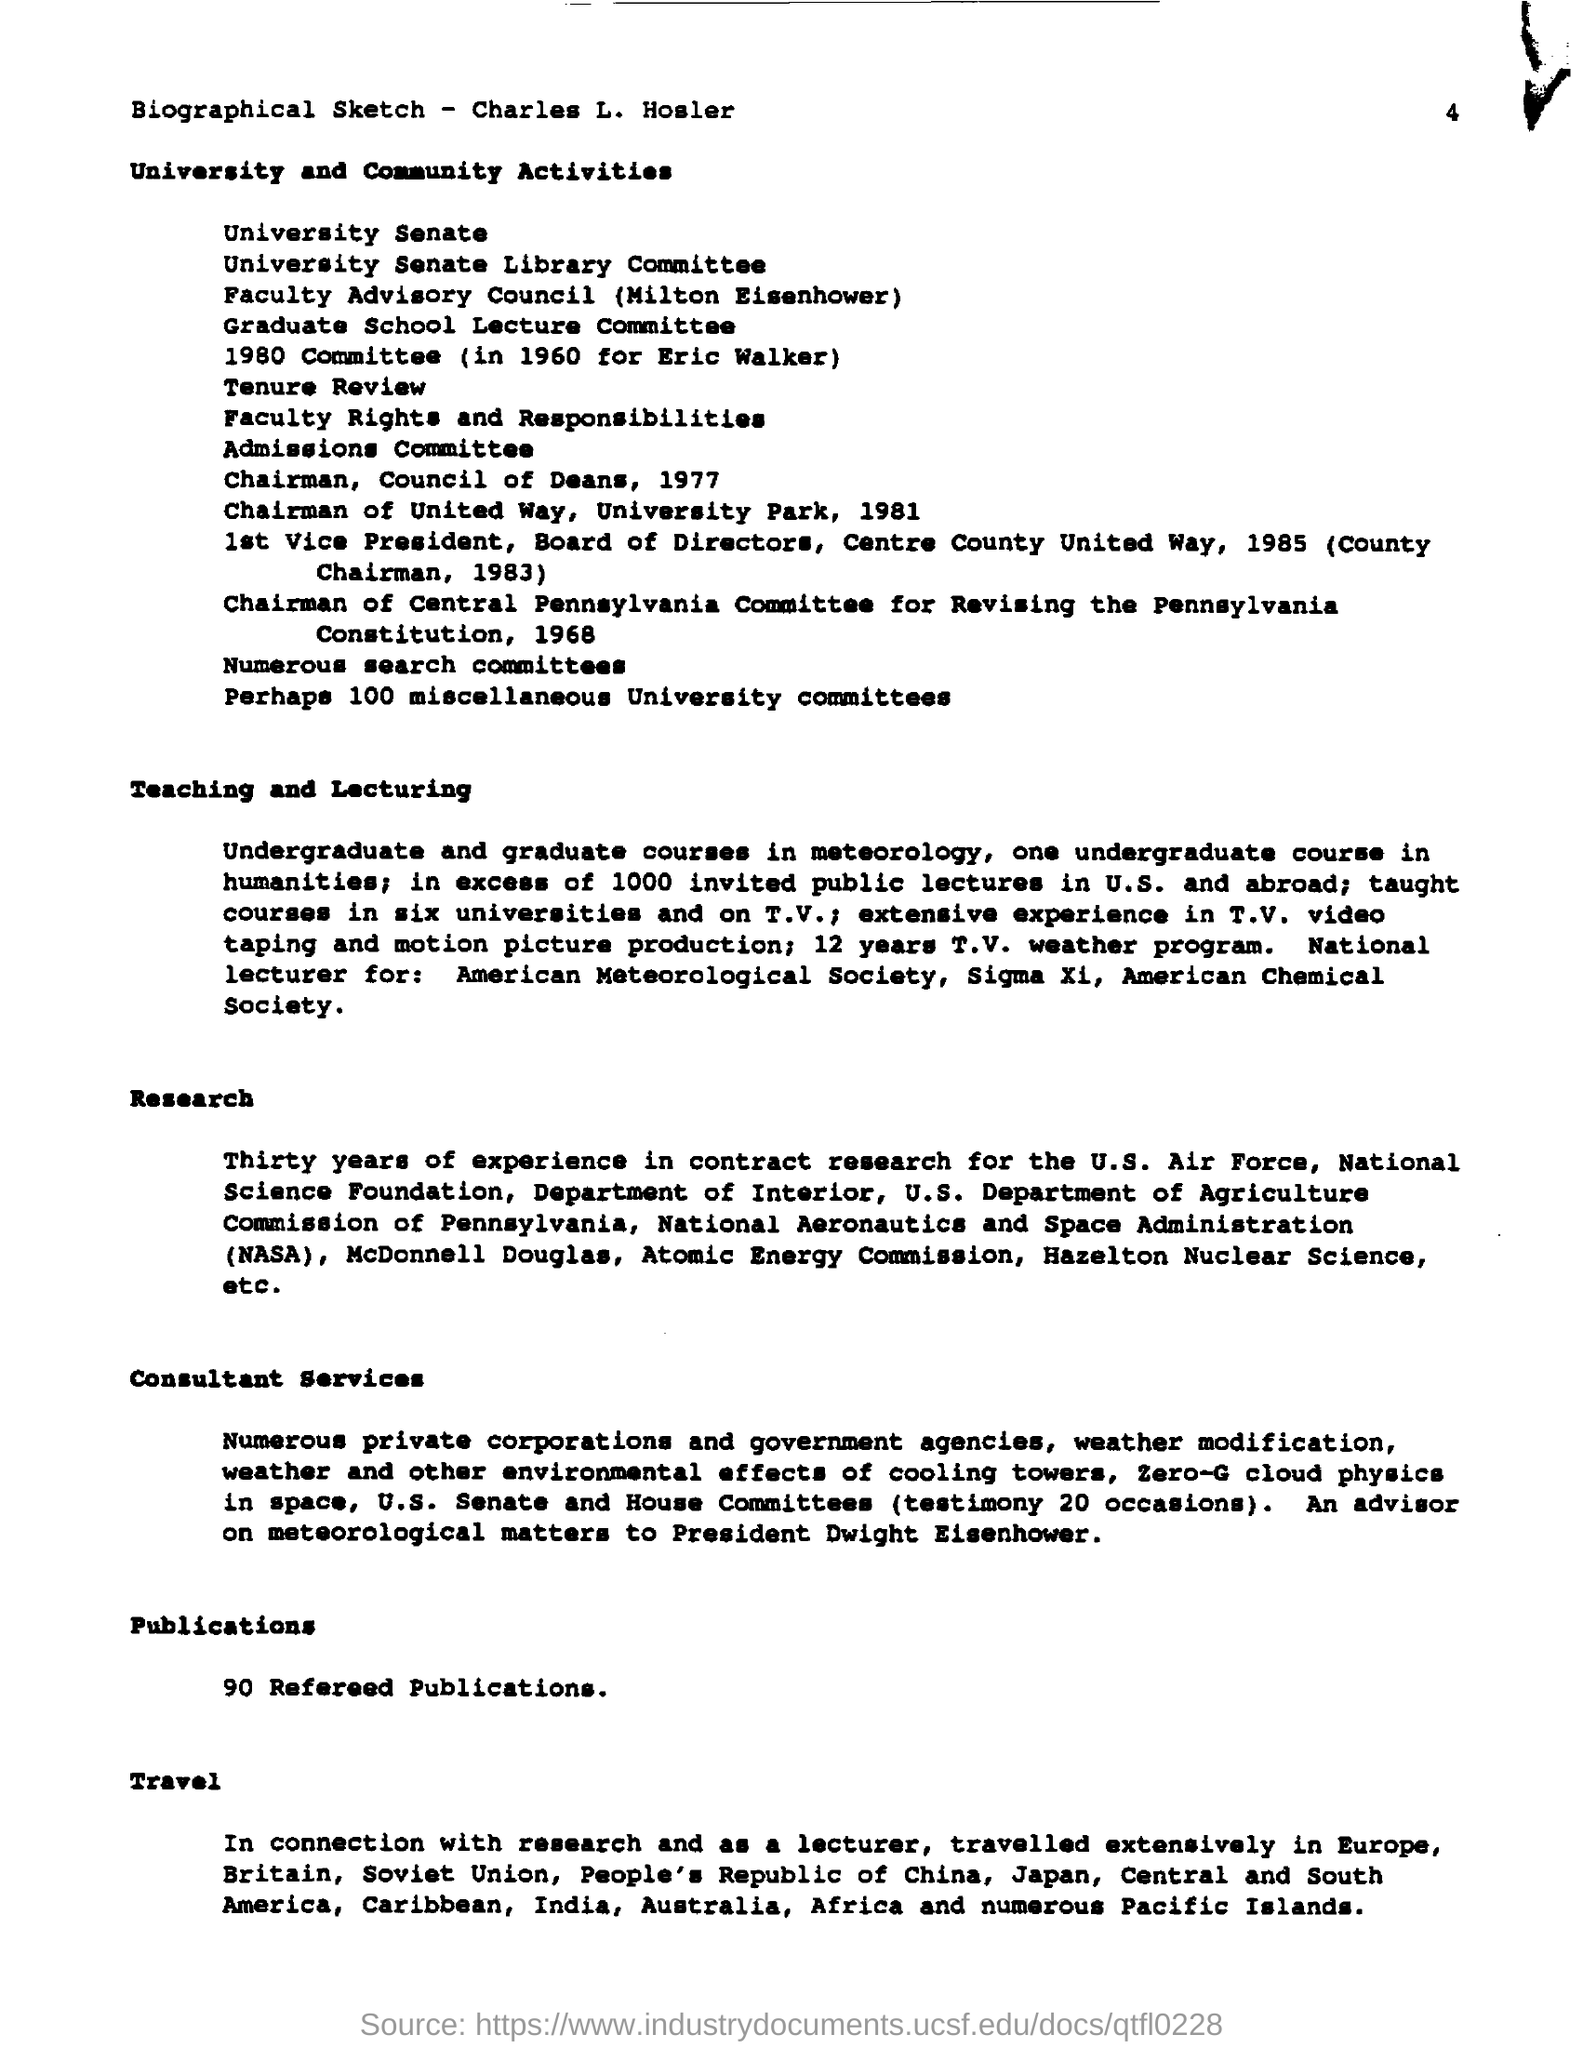What is the last title in the document?
Give a very brief answer. Travel. What is the second last title in the document?
Ensure brevity in your answer.  Publications. 